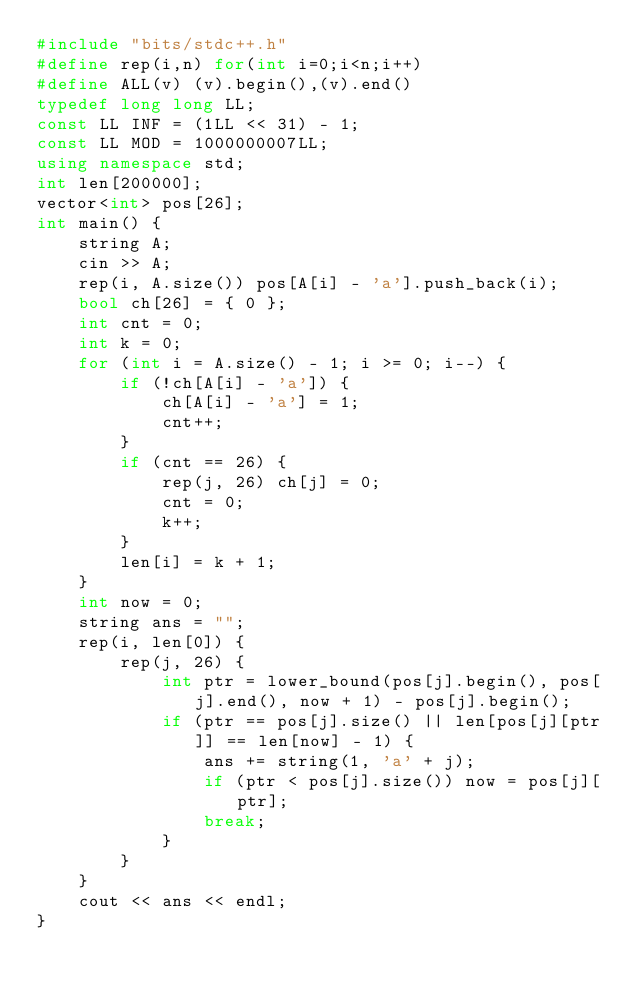Convert code to text. <code><loc_0><loc_0><loc_500><loc_500><_C++_>#include "bits/stdc++.h"
#define rep(i,n) for(int i=0;i<n;i++)
#define ALL(v) (v).begin(),(v).end()
typedef long long LL;
const LL INF = (1LL << 31) - 1;
const LL MOD = 1000000007LL;
using namespace std;
int len[200000];
vector<int> pos[26];
int main() {
	string A;
	cin >> A;
	rep(i, A.size()) pos[A[i] - 'a'].push_back(i);
	bool ch[26] = { 0 };
	int cnt = 0;
	int k = 0;
	for (int i = A.size() - 1; i >= 0; i--) {
		if (!ch[A[i] - 'a']) {
			ch[A[i] - 'a'] = 1;
			cnt++;
		}
		if (cnt == 26) {
			rep(j, 26) ch[j] = 0;
			cnt = 0;
			k++;
		}
		len[i] = k + 1;
	}
	int now = 0;
	string ans = "";
	rep(i, len[0]) {
		rep(j, 26) {
			int ptr = lower_bound(pos[j].begin(), pos[j].end(), now + 1) - pos[j].begin();
			if (ptr == pos[j].size() || len[pos[j][ptr]] == len[now] - 1) {
				ans += string(1, 'a' + j);
				if (ptr < pos[j].size()) now = pos[j][ptr];
				break;
			}
		}
	}
	cout << ans << endl;
}</code> 